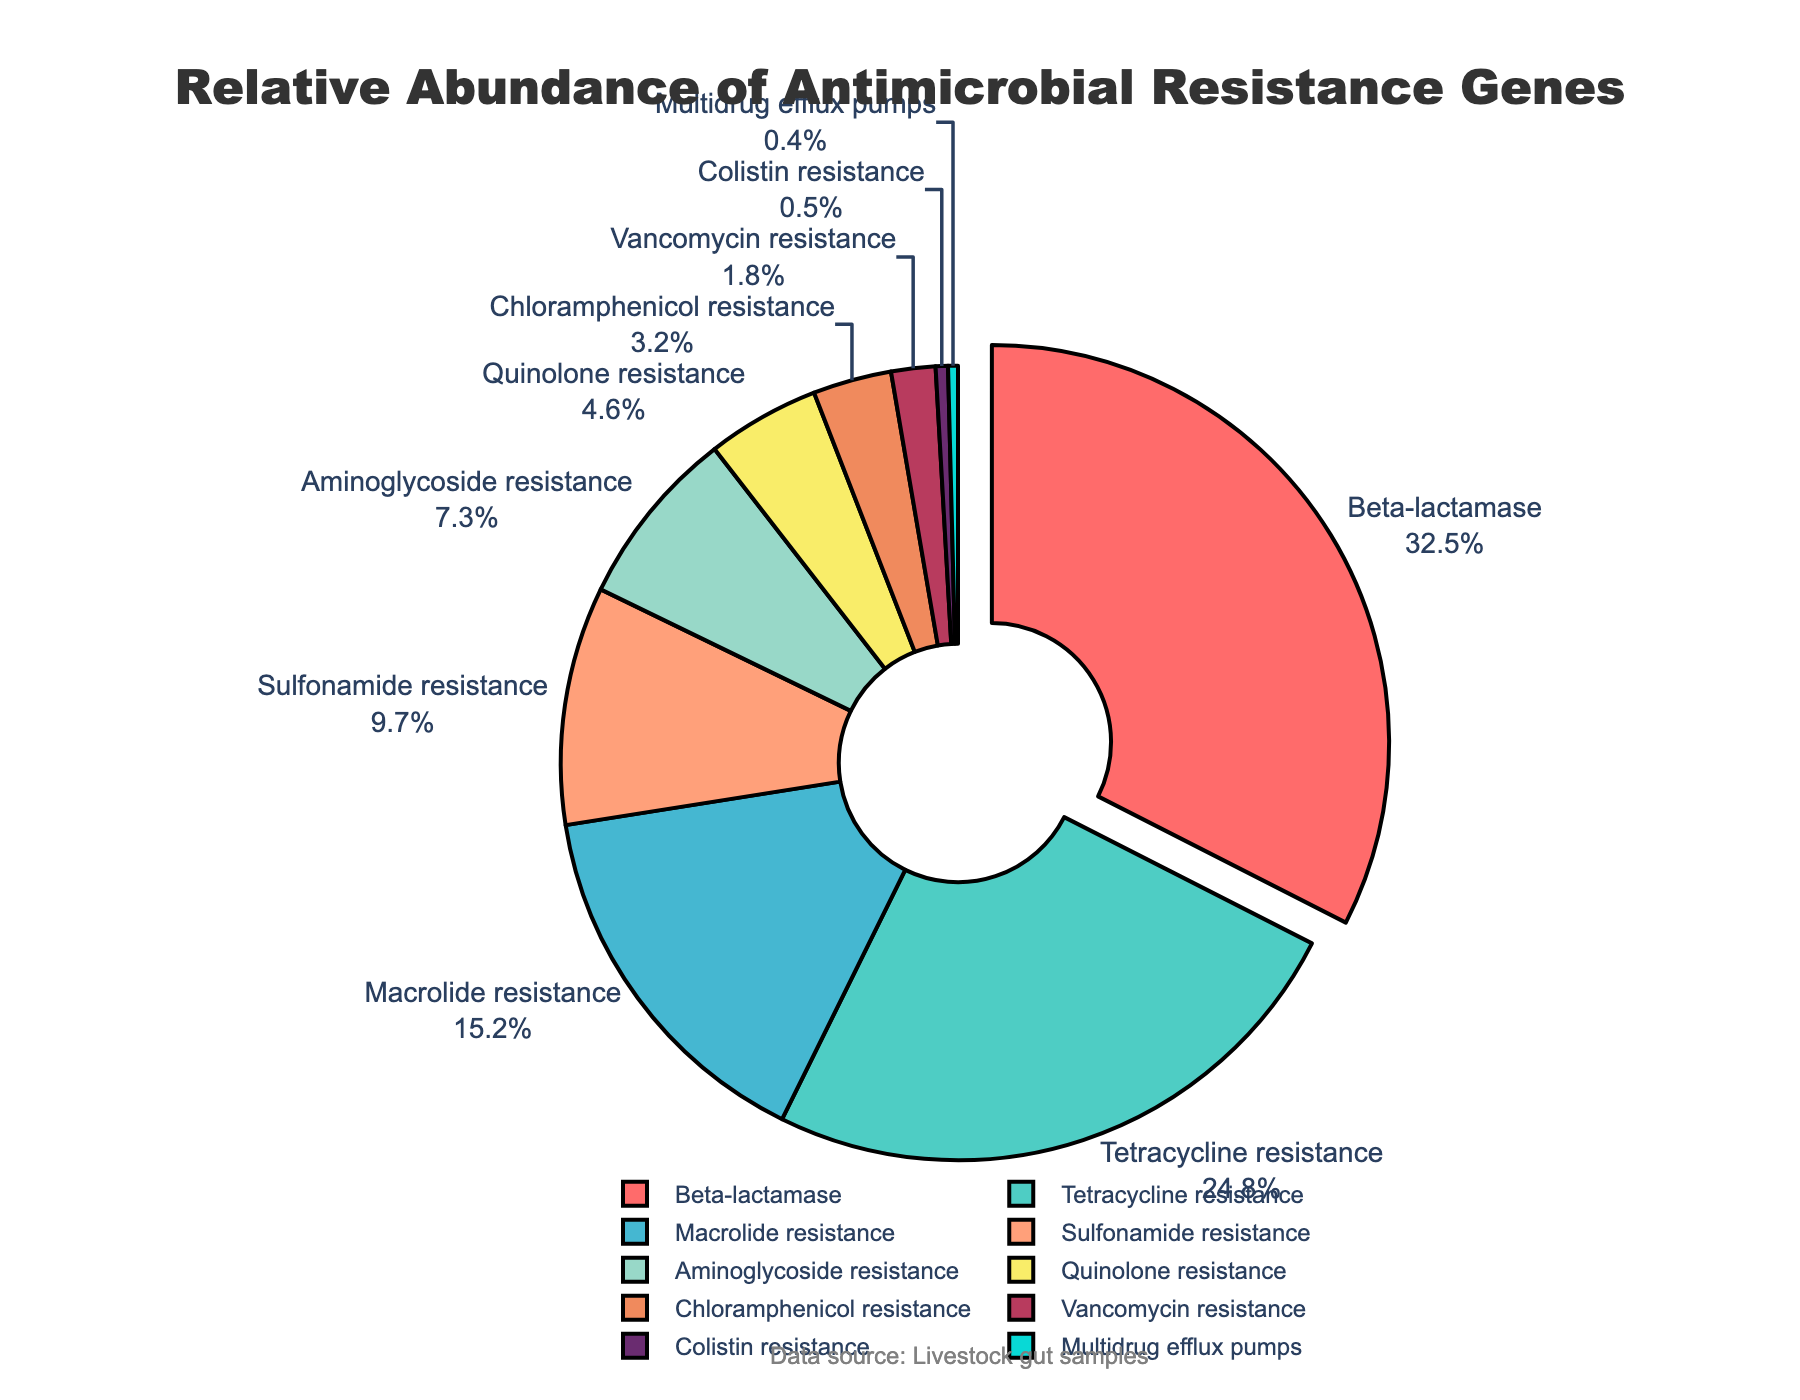Which class of antimicrobial resistance genes is the most abundant? The class with the highest relative abundance can be identified by looking at the segment of the pie chart with the largest area. The "Beta-lactamase" class has the largest segment at 32.5%.
Answer: Beta-lactamase Which antimicrobial resistance gene class has a relative abundance less than 5%? By examining the slices of the pie chart with smaller areas, the classes with less than 5% abundance are "Quinolone resistance", "Chloramphenicol resistance", "Vancomycin resistance", "Colistin resistance", and "Multidrug efflux pumps".
Answer: Quinolone resistance, Chloramphenicol resistance, Vancomycin resistance, Colistin resistance, Multidrug efflux pumps What is the combined relative abundance of "Sulfonamide resistance" and "Aminoglycoside resistance"? To find the combined abundance, sum the relative abundances of "Sulfonamide resistance" (9.7%) and "Aminoglycoside resistance" (7.3%). The calculation is 9.7 + 7.3.
Answer: 17.0% How much more abundant is "Tetracycline resistance" compared to "Macrolide resistance"? Subtract the relative abundance of "Macrolide resistance" (15.2%) from that of "Tetracycline resistance" (24.8%). The calculation is 24.8 - 15.2.
Answer: 9.6% Which antimicrobial resistance gene classes have a relative abundance higher than 10%? By identifying pie chart slices that are larger and labeled with abundances greater than 10%, the classes are "Beta-lactamase" (32.5%), "Tetracycline resistance" (24.8%), and "Macrolide resistance" (15.2%).
Answer: Beta-lactamase, Tetracycline resistance, Macrolide resistance What is the color used for the "Quinolone resistance" class in the pie chart? The color of each segment can be identified by matching the labels with the corresponding color segment. The "Quinolone resistance" class is shown in a blue color.
Answer: Blue Compare the combined relative abundance of "Vancomycin resistance" and "Colistin resistance" to "Macrolide resistance". Which is larger, and by how much? First, sum the relative abundances of "Vancomycin resistance" (1.8%) and "Colistin resistance" (0.5%) to get 1.8 + 0.5 = 2.3%. Then, compare this with "Macrolide resistance" (15.2%). The difference is 15.2 - 2.3.
Answer: Macrolide resistance is 12.9% larger What is the relative abundance of the least represented antimicrobial resistance gene class? Identify the segment with the smallest area. The "Multidrug efflux pumps" class has the smallest area with a relative abundance of 0.4%.
Answer: 0.4% Is the relative abundance of "Chloramphenicol resistance" closer to "Aminoglycoside resistance" or "Quinolone resistance"? Calculate the difference between "Chloramphenicol resistance" (3.2%) and both "Aminoglycoside resistance" (7.3%) and "Quinolone resistance" (4.6%). The differences are 7.3 - 3.2 = 4.1% and 4.6 - 3.2 = 1.4%. Thus, it is closer to "Quinolone resistance".
Answer: Quinolone resistance Which segment of the pie chart is pulled out and why? The segment that is slightly separated from the rest highlights the most abundant class for emphasis. The "Beta-lactamase" segment is pulled out, emphasizing its highest relative abundance of 32.5%.
Answer: Beta-lactamase, to emphasize its abundance 